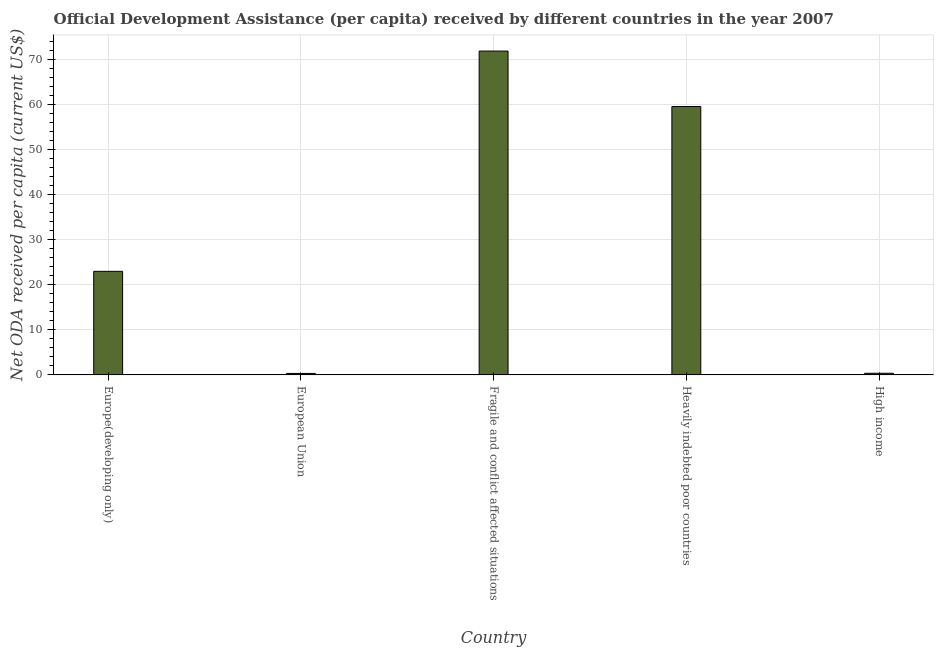Does the graph contain grids?
Offer a very short reply. Yes. What is the title of the graph?
Provide a succinct answer. Official Development Assistance (per capita) received by different countries in the year 2007. What is the label or title of the Y-axis?
Make the answer very short. Net ODA received per capita (current US$). What is the net oda received per capita in Fragile and conflict affected situations?
Ensure brevity in your answer.  71.79. Across all countries, what is the maximum net oda received per capita?
Ensure brevity in your answer.  71.79. Across all countries, what is the minimum net oda received per capita?
Your answer should be compact. 0.33. In which country was the net oda received per capita maximum?
Your response must be concise. Fragile and conflict affected situations. In which country was the net oda received per capita minimum?
Keep it short and to the point. European Union. What is the sum of the net oda received per capita?
Give a very brief answer. 154.94. What is the difference between the net oda received per capita in Europe(developing only) and Fragile and conflict affected situations?
Keep it short and to the point. -48.83. What is the average net oda received per capita per country?
Your answer should be compact. 30.99. What is the median net oda received per capita?
Make the answer very short. 22.96. In how many countries, is the net oda received per capita greater than 72 US$?
Ensure brevity in your answer.  0. What is the ratio of the net oda received per capita in Europe(developing only) to that in Fragile and conflict affected situations?
Your response must be concise. 0.32. Is the net oda received per capita in Europe(developing only) less than that in Fragile and conflict affected situations?
Keep it short and to the point. Yes. Is the difference between the net oda received per capita in European Union and Heavily indebted poor countries greater than the difference between any two countries?
Provide a short and direct response. No. What is the difference between the highest and the second highest net oda received per capita?
Offer a very short reply. 12.29. What is the difference between the highest and the lowest net oda received per capita?
Offer a very short reply. 71.46. In how many countries, is the net oda received per capita greater than the average net oda received per capita taken over all countries?
Your response must be concise. 2. How many bars are there?
Provide a short and direct response. 5. How many countries are there in the graph?
Offer a terse response. 5. What is the difference between two consecutive major ticks on the Y-axis?
Give a very brief answer. 10. Are the values on the major ticks of Y-axis written in scientific E-notation?
Provide a succinct answer. No. What is the Net ODA received per capita (current US$) in Europe(developing only)?
Make the answer very short. 22.96. What is the Net ODA received per capita (current US$) of European Union?
Offer a terse response. 0.33. What is the Net ODA received per capita (current US$) of Fragile and conflict affected situations?
Give a very brief answer. 71.79. What is the Net ODA received per capita (current US$) in Heavily indebted poor countries?
Ensure brevity in your answer.  59.5. What is the Net ODA received per capita (current US$) in High income?
Give a very brief answer. 0.36. What is the difference between the Net ODA received per capita (current US$) in Europe(developing only) and European Union?
Make the answer very short. 22.63. What is the difference between the Net ODA received per capita (current US$) in Europe(developing only) and Fragile and conflict affected situations?
Offer a very short reply. -48.83. What is the difference between the Net ODA received per capita (current US$) in Europe(developing only) and Heavily indebted poor countries?
Ensure brevity in your answer.  -36.54. What is the difference between the Net ODA received per capita (current US$) in Europe(developing only) and High income?
Your response must be concise. 22.6. What is the difference between the Net ODA received per capita (current US$) in European Union and Fragile and conflict affected situations?
Make the answer very short. -71.46. What is the difference between the Net ODA received per capita (current US$) in European Union and Heavily indebted poor countries?
Keep it short and to the point. -59.17. What is the difference between the Net ODA received per capita (current US$) in European Union and High income?
Provide a short and direct response. -0.04. What is the difference between the Net ODA received per capita (current US$) in Fragile and conflict affected situations and Heavily indebted poor countries?
Provide a succinct answer. 12.29. What is the difference between the Net ODA received per capita (current US$) in Fragile and conflict affected situations and High income?
Offer a very short reply. 71.42. What is the difference between the Net ODA received per capita (current US$) in Heavily indebted poor countries and High income?
Give a very brief answer. 59.13. What is the ratio of the Net ODA received per capita (current US$) in Europe(developing only) to that in European Union?
Provide a succinct answer. 70.47. What is the ratio of the Net ODA received per capita (current US$) in Europe(developing only) to that in Fragile and conflict affected situations?
Your answer should be compact. 0.32. What is the ratio of the Net ODA received per capita (current US$) in Europe(developing only) to that in Heavily indebted poor countries?
Offer a very short reply. 0.39. What is the ratio of the Net ODA received per capita (current US$) in Europe(developing only) to that in High income?
Your response must be concise. 62.96. What is the ratio of the Net ODA received per capita (current US$) in European Union to that in Fragile and conflict affected situations?
Ensure brevity in your answer.  0.01. What is the ratio of the Net ODA received per capita (current US$) in European Union to that in Heavily indebted poor countries?
Offer a very short reply. 0.01. What is the ratio of the Net ODA received per capita (current US$) in European Union to that in High income?
Ensure brevity in your answer.  0.89. What is the ratio of the Net ODA received per capita (current US$) in Fragile and conflict affected situations to that in Heavily indebted poor countries?
Your answer should be compact. 1.21. What is the ratio of the Net ODA received per capita (current US$) in Fragile and conflict affected situations to that in High income?
Offer a very short reply. 196.85. What is the ratio of the Net ODA received per capita (current US$) in Heavily indebted poor countries to that in High income?
Provide a short and direct response. 163.14. 